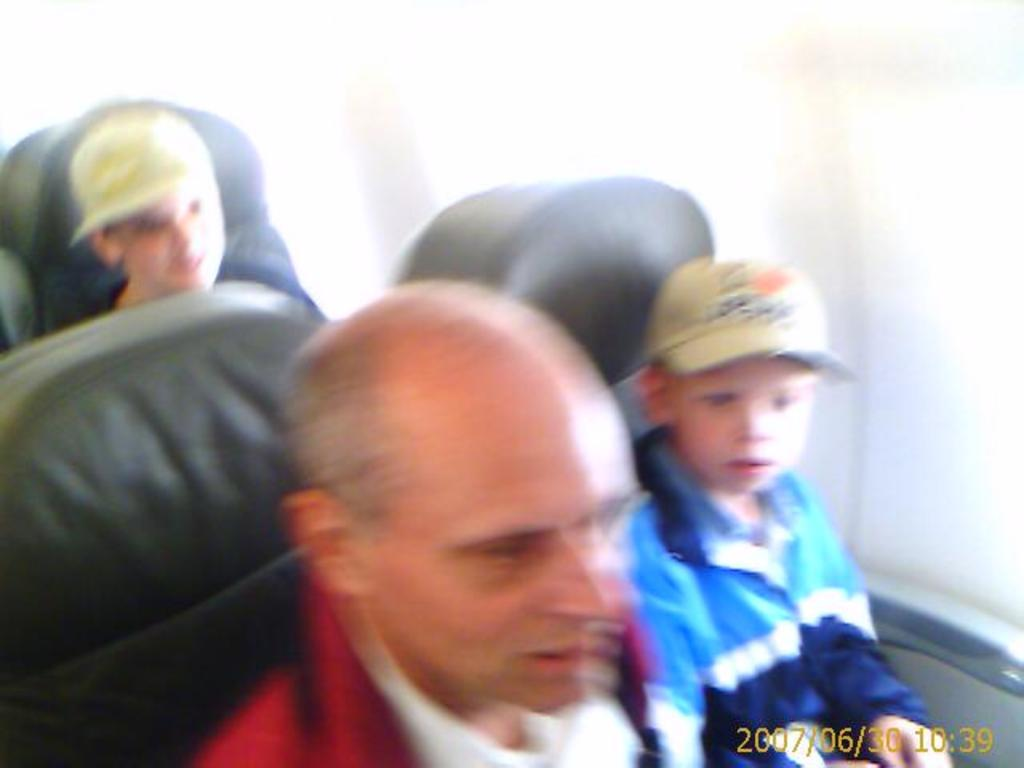What are the people in the image doing? The people in the image are sitting on chairs. What can be seen behind the people in the image? The background of the image is visible. Is there any additional information provided in the image? Yes, the date and time are displayed in the bottom right corner of the image. What type of cake is being served to the people in the image? There is no cake present in the image; the people are sitting on chairs. How do the people say good-bye to each other in the image? There is no indication of people saying good-bye in the image; they are simply sitting on chairs. 